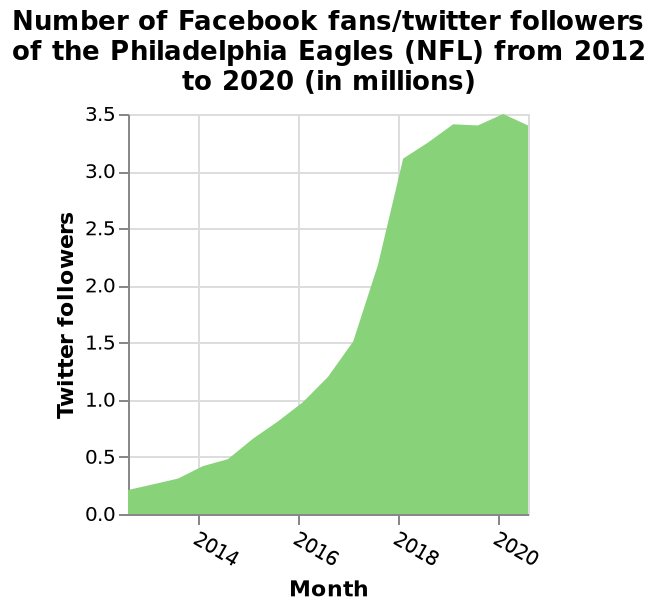<image>
What does the x-axis represent?  The x-axis represents the years 2014 to 2020, marked by month. When did the number of followers peak? The number of followers peaked in 2020. please summary the statistics and relations of the chart There were less than 500,000 Facebook fans/twitter followers of the Philadelphia Eagles in 2012 which rose to 3.5 million in 2020. From 2012 to 2018 there has been a rapid increase in Facebook fans/twitter followers from under 500,000 to just over 3 million. 2018 to 2020 showed a much slower increase in Facebook fans/Instagram followers rising less than 500,000 from just above 3 million to 3.5 million. Describe the following image in detail This is a area graph named Number of Facebook fans/twitter followers of the Philadelphia Eagles (NFL) from 2012 to 2020 (in millions). The y-axis measures Twitter followers with a linear scale from 0.0 to 3.5. There is a linear scale from 2014 to 2020 along the x-axis, marked Month. Does the x-axis represent the years 2020 to 2014, marked by week? No. The x-axis represents the years 2014 to 2020, marked by month. 